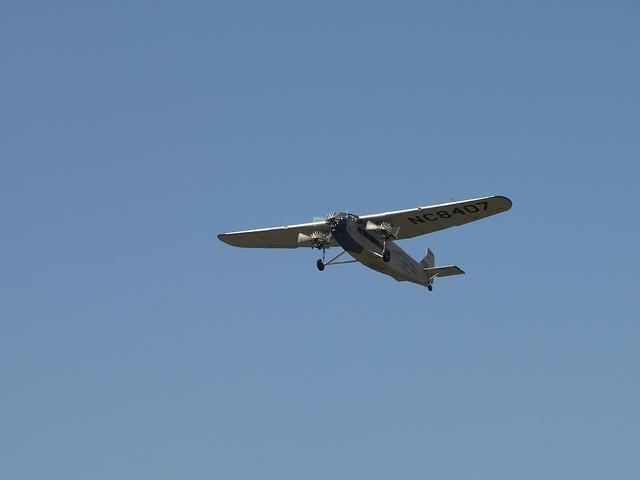What color is the sky?
Short answer required. Blue. Is this a commercial airliner?
Quick response, please. No. What is flying?
Keep it brief. Plane. How many people are in the plane?
Give a very brief answer. 2. Is it sunny out?
Concise answer only. Yes. What is the number on the plane?
Answer briefly. Hc8407. 